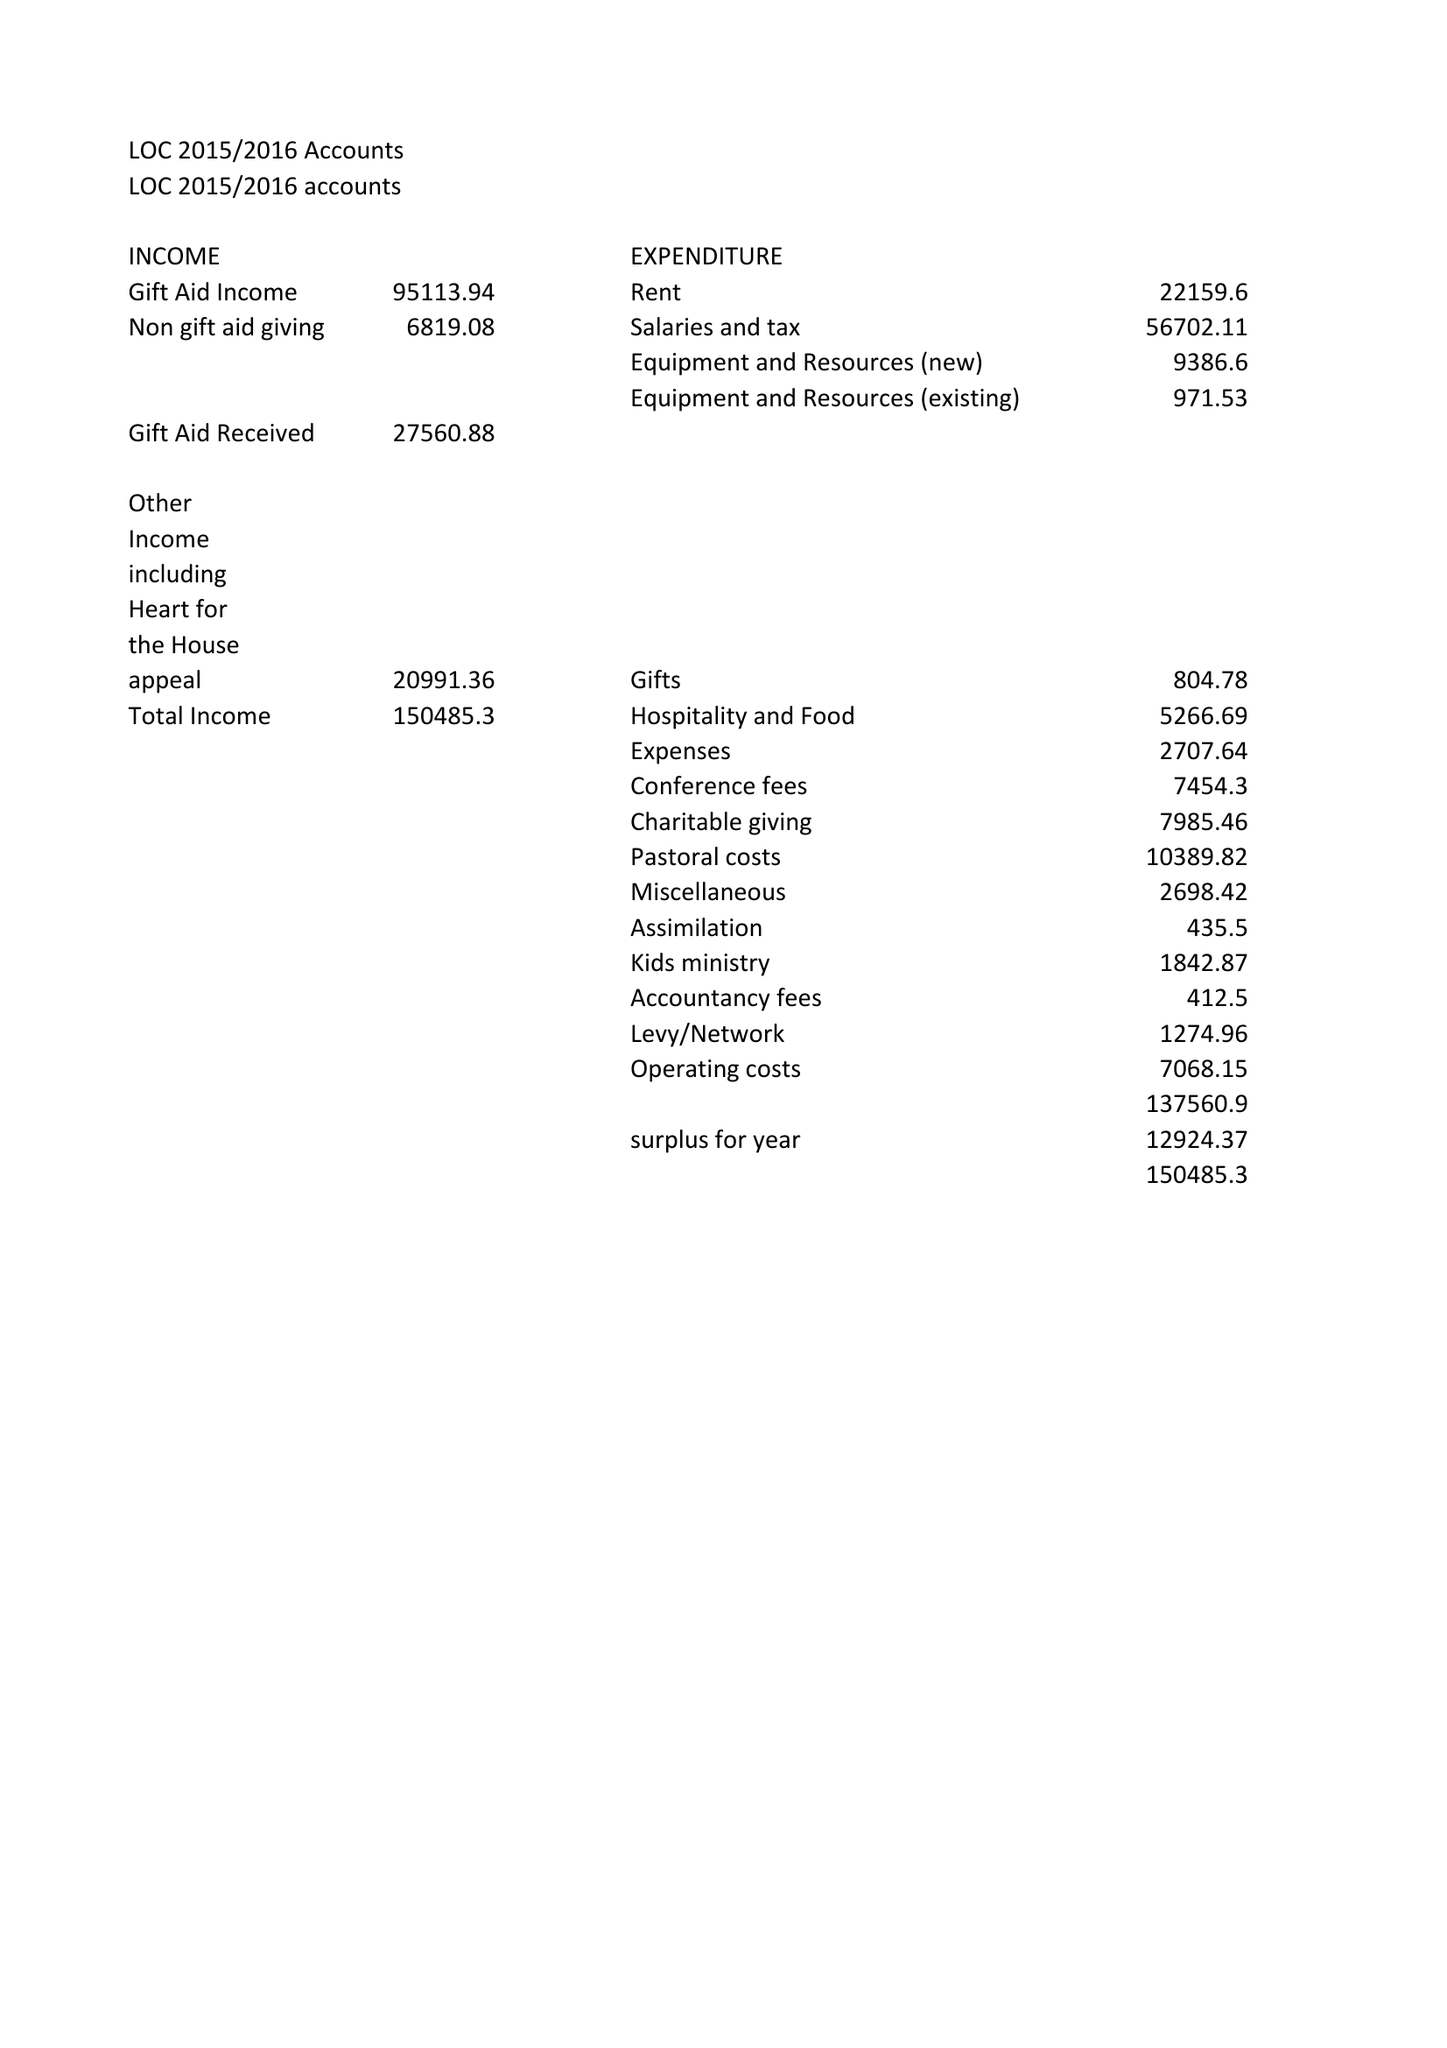What is the value for the address__street_line?
Answer the question using a single word or phrase. None 